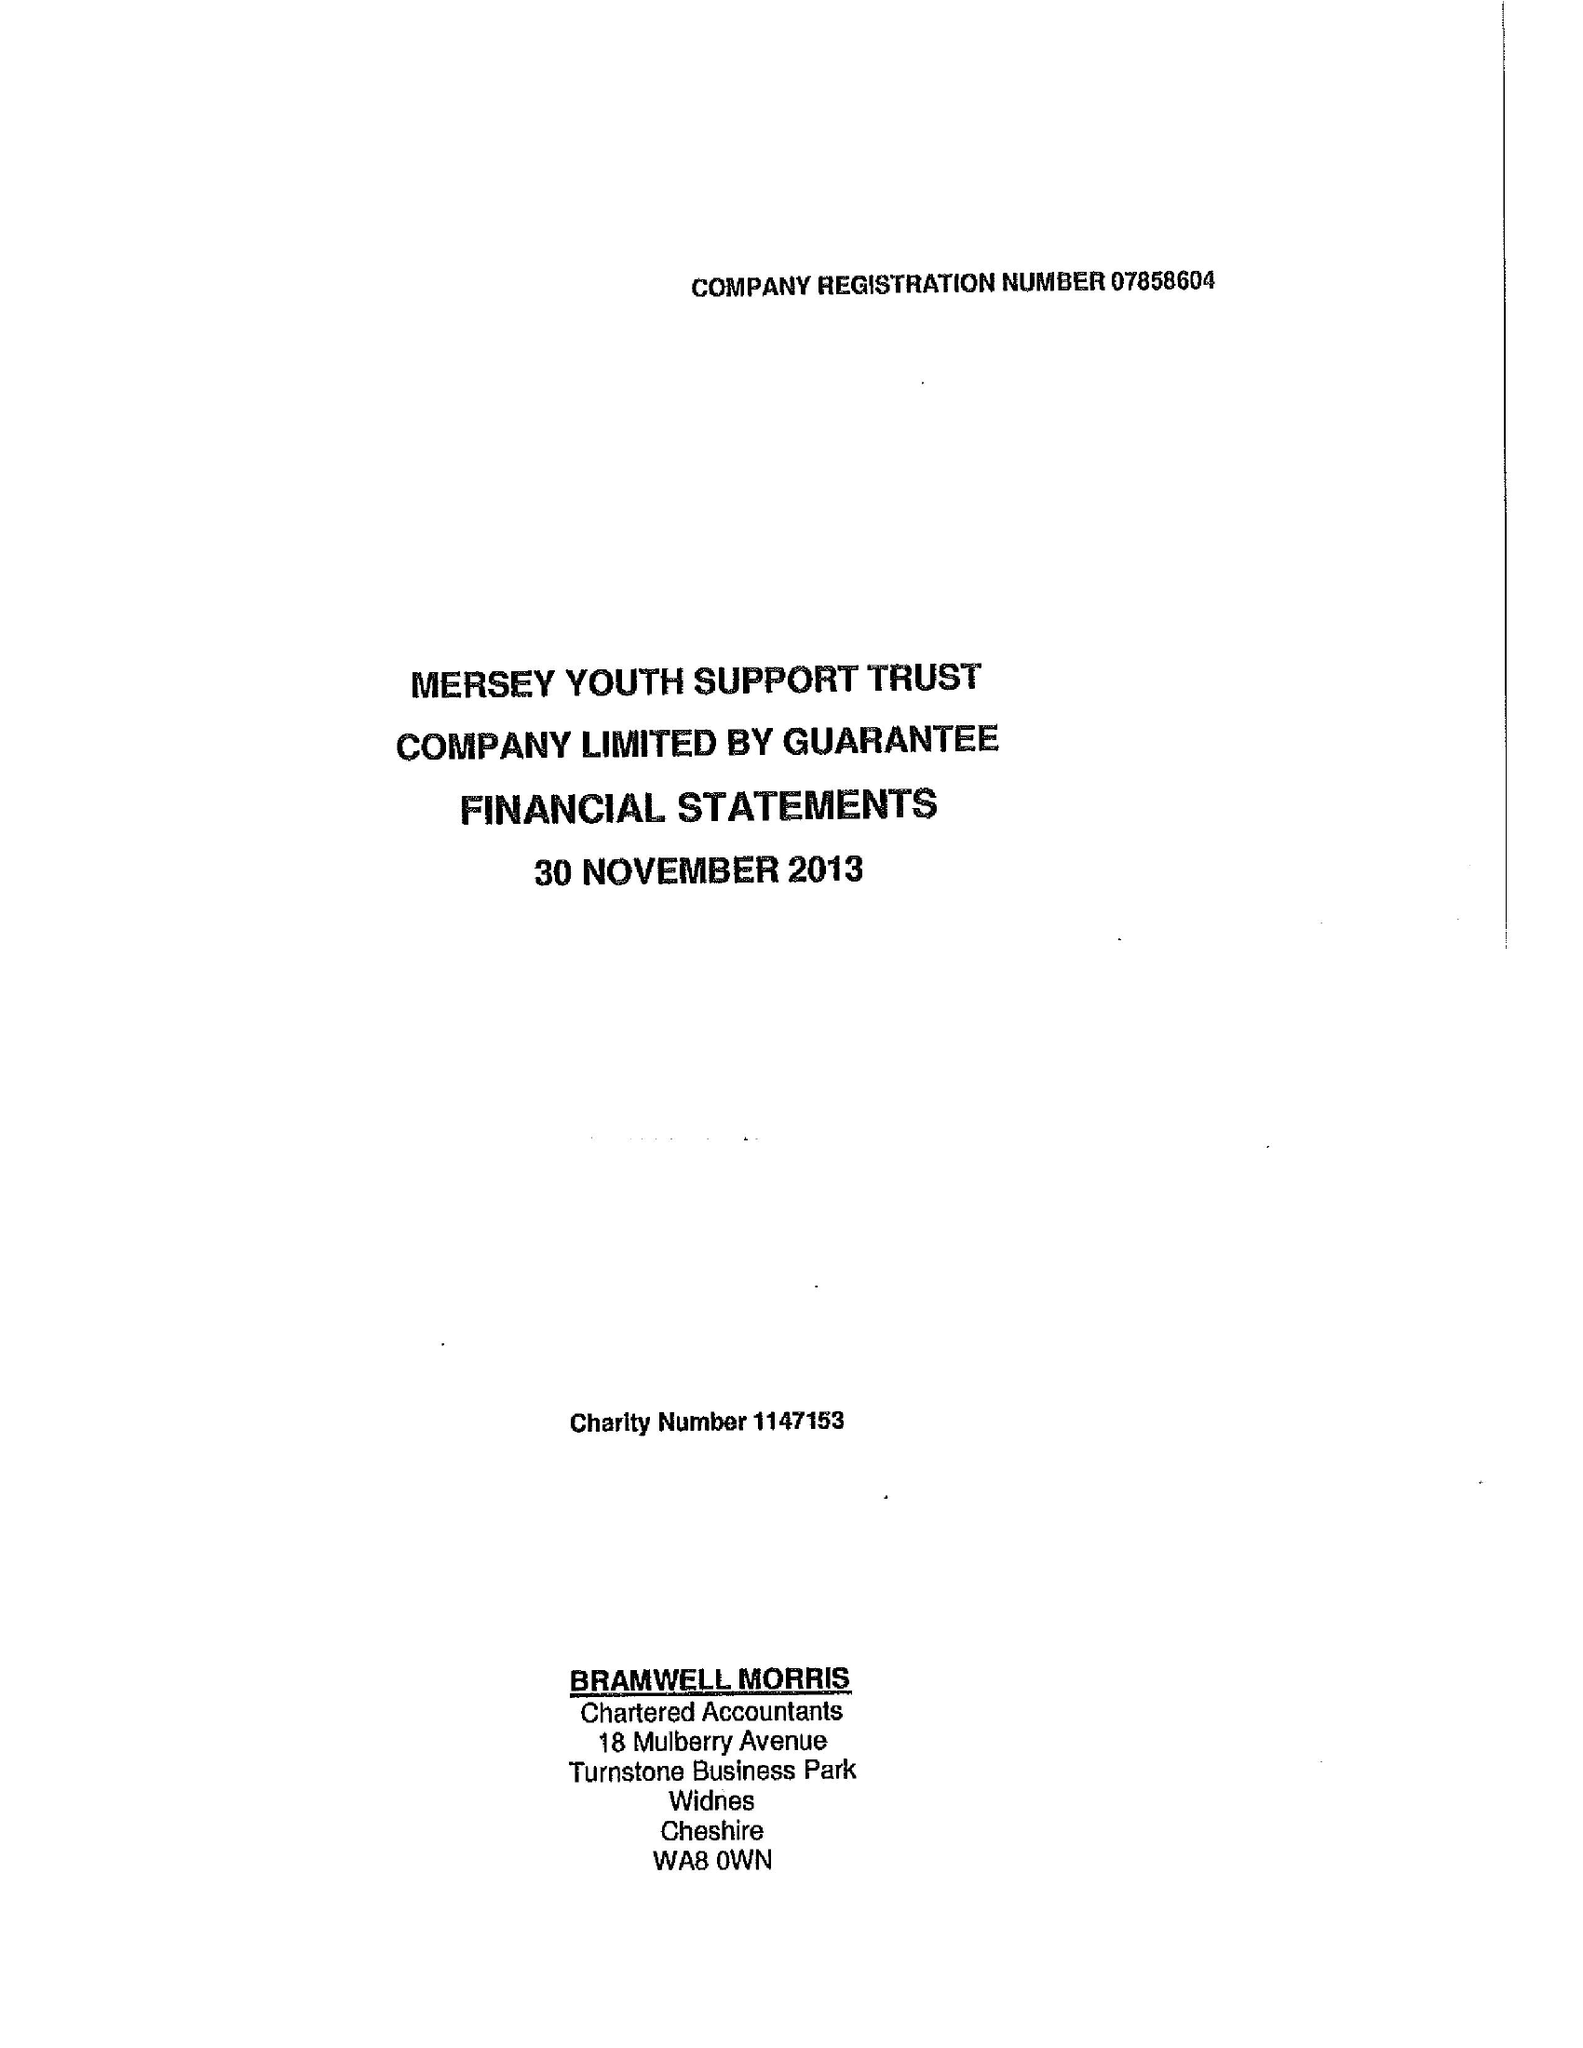What is the value for the charity_name?
Answer the question using a single word or phrase. Mersey Youth Support Trust 